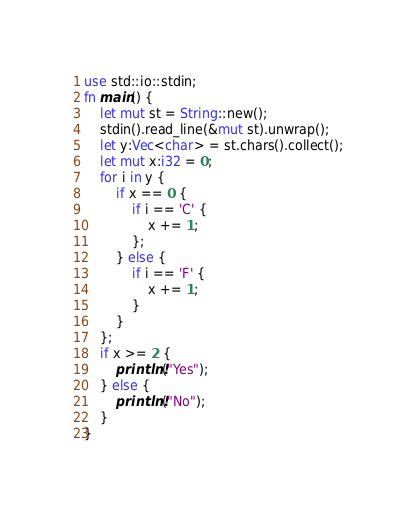<code> <loc_0><loc_0><loc_500><loc_500><_Rust_>use std::io::stdin;
fn main() {
    let mut st = String::new();
    stdin().read_line(&mut st).unwrap();
    let y:Vec<char> = st.chars().collect();
    let mut x:i32 = 0;
    for i in y {
        if x == 0 {
            if i == 'C' {
                x += 1;
            };
        } else {
            if i == 'F' {
                x += 1;
            }
        }
    };
    if x >= 2 {
        println!("Yes");
    } else {
        println!("No");
    }
}</code> 